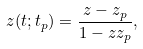<formula> <loc_0><loc_0><loc_500><loc_500>z ( t ; t _ { p } ) = \frac { z - z _ { p } } { 1 - z z _ { p } } ,</formula> 